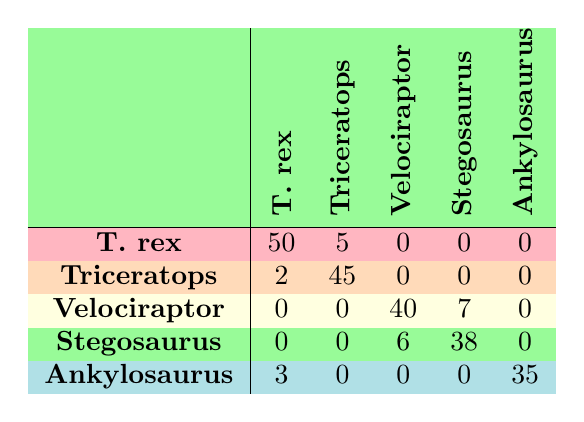What is the True Positive value for Tyrannosaurus rex? The True Positive value for Tyrannosaurus rex is directly listed in the table under the T. rex row. It shows a value of 50.
Answer: 50 What is the total number of False Positives across all classes? To find the total False Positives, we sum the False Positive values for each dinosaur: 5 (T. rex) + 2 (Triceratops) + 7 (Velociraptor) + 6 (Stegosaurus) + 3 (Ankylosaurus) = 23.
Answer: 23 Is Triceratops horridus the most accurately classified species? To determine this, we compare the True Positive and false negative values across all species. Triceratops has 45 True Positives and 5 False Negatives, which gives it a high accuracy, but we must also consider other species. However, T. rex has 50 True Positives and only 3 False Negatives, indicating it is the most accurately classified species. Thus, the statement is false.
Answer: No How many False Negatives does Velociraptor mongoliensis have compared to Ankylosaurus magniventris? Velociraptor mongoliensis has 8 False Negatives while Ankylosaurus magniventris has 7. To compare, we see that Velociraptor has one more False Negative than Ankylosaurus.
Answer: Velociraptor has 1 more False Negative What is the average True Positive value for all the species mentioned? We calculate the average True Positive by adding all True Positive values: 50 (T. rex) + 45 (Triceratops) + 40 (Velociraptor) + 38 (Stegosaurus) + 35 (Ankylosaurus) = 208. There are 5 species, so we divide by 5: 208 / 5 = 41.6.
Answer: 41.6 